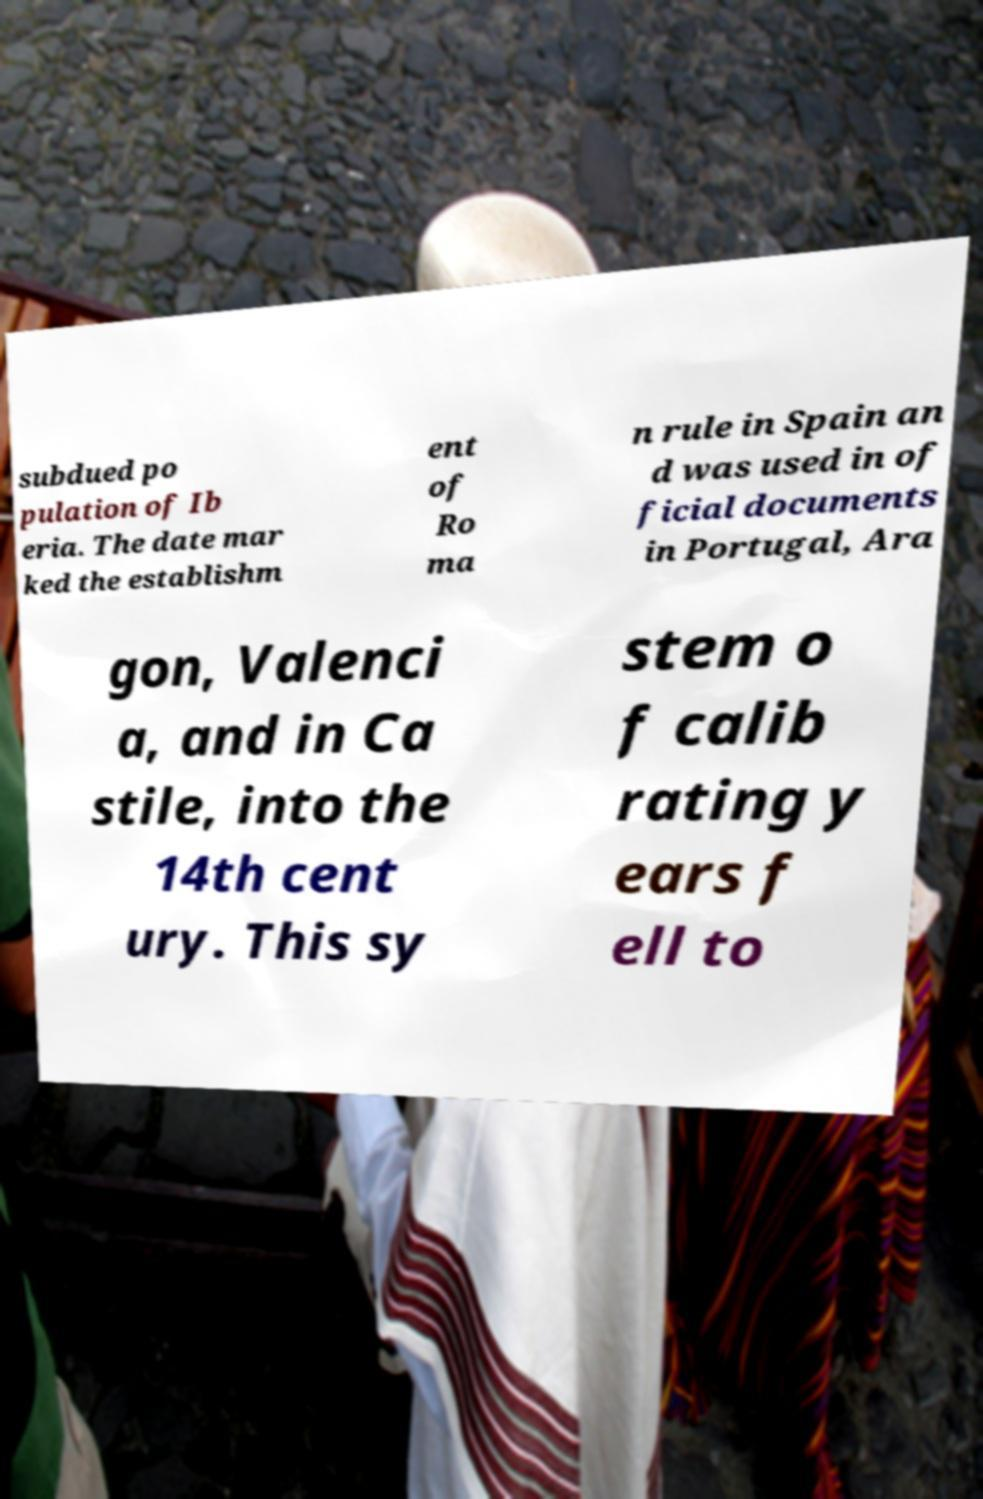Can you read and provide the text displayed in the image?This photo seems to have some interesting text. Can you extract and type it out for me? subdued po pulation of Ib eria. The date mar ked the establishm ent of Ro ma n rule in Spain an d was used in of ficial documents in Portugal, Ara gon, Valenci a, and in Ca stile, into the 14th cent ury. This sy stem o f calib rating y ears f ell to 